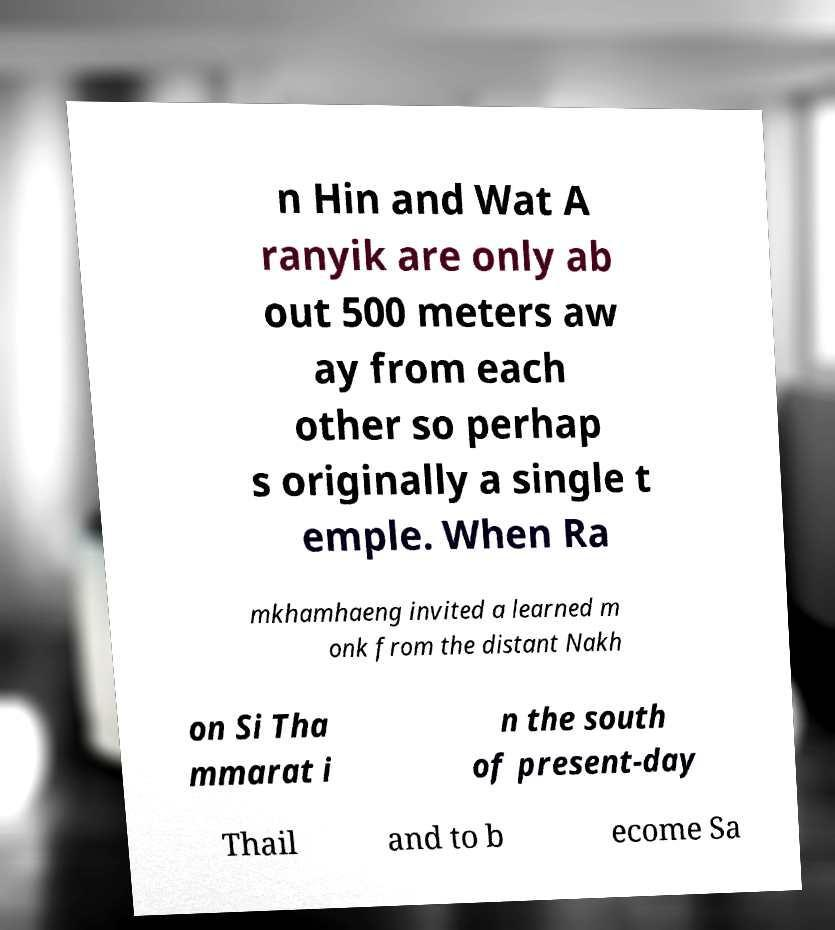I need the written content from this picture converted into text. Can you do that? n Hin and Wat A ranyik are only ab out 500 meters aw ay from each other so perhap s originally a single t emple. When Ra mkhamhaeng invited a learned m onk from the distant Nakh on Si Tha mmarat i n the south of present-day Thail and to b ecome Sa 